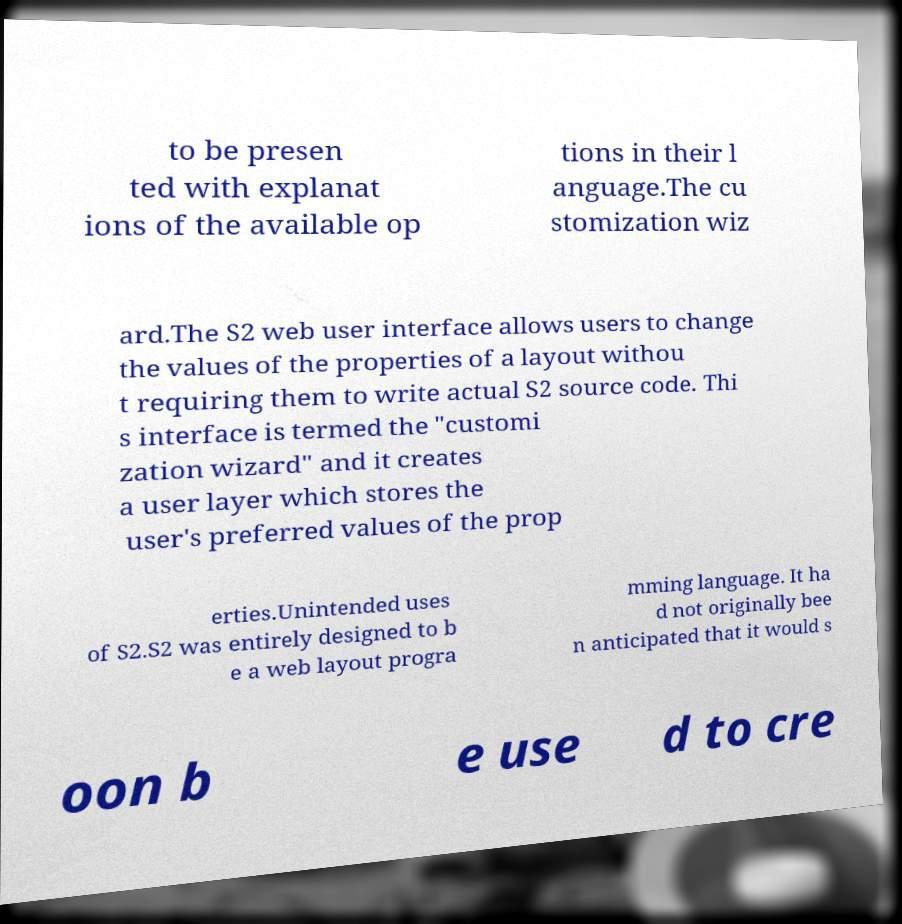Please identify and transcribe the text found in this image. to be presen ted with explanat ions of the available op tions in their l anguage.The cu stomization wiz ard.The S2 web user interface allows users to change the values of the properties of a layout withou t requiring them to write actual S2 source code. Thi s interface is termed the "customi zation wizard" and it creates a user layer which stores the user's preferred values of the prop erties.Unintended uses of S2.S2 was entirely designed to b e a web layout progra mming language. It ha d not originally bee n anticipated that it would s oon b e use d to cre 